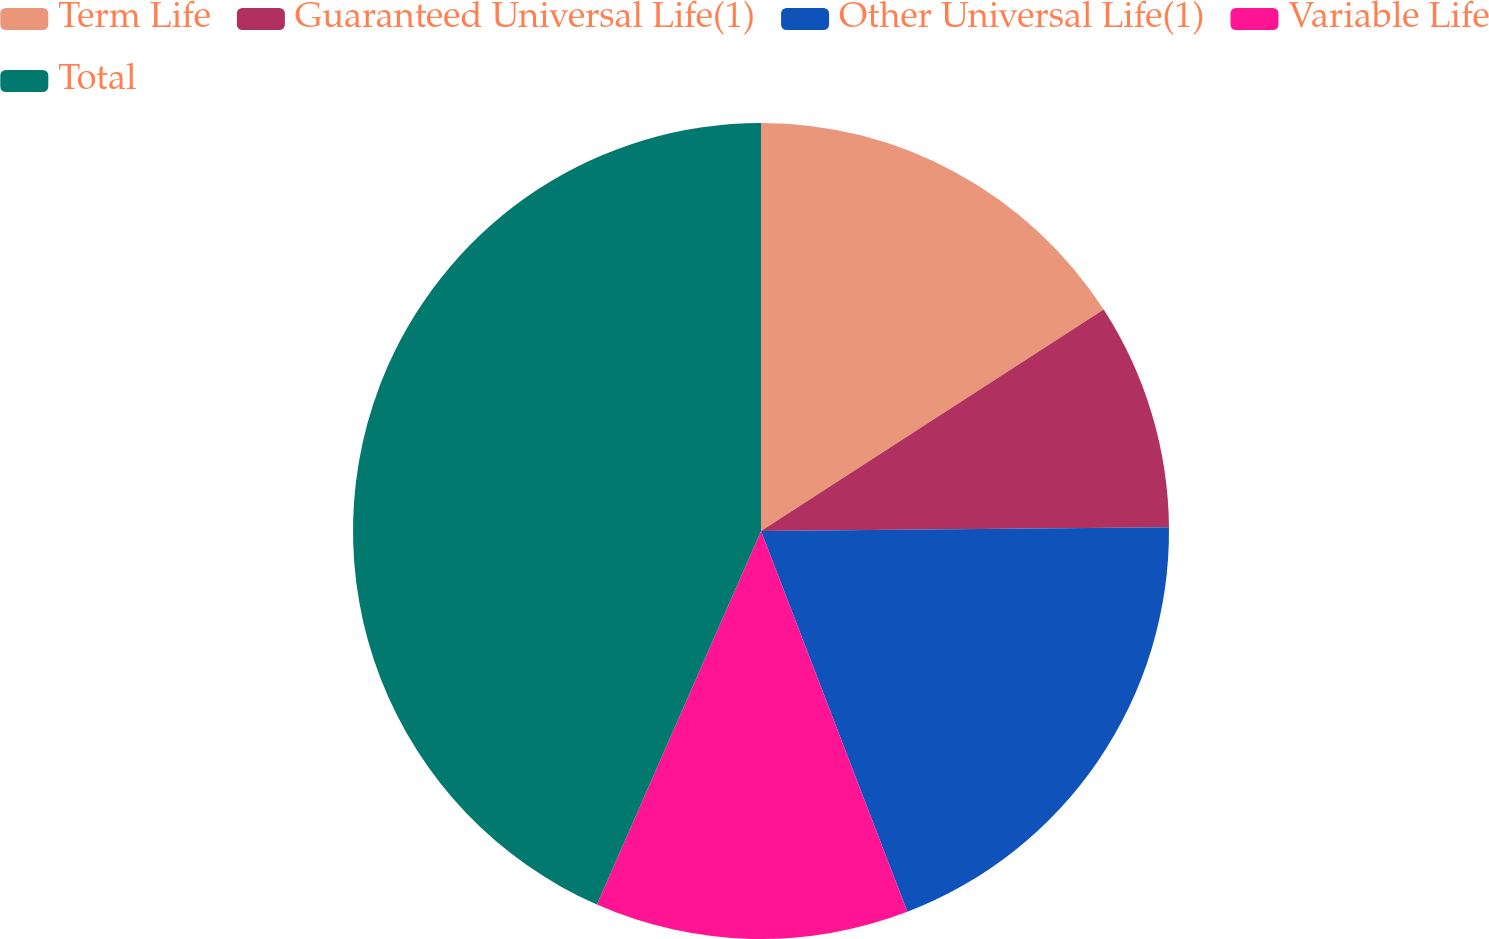Convert chart. <chart><loc_0><loc_0><loc_500><loc_500><pie_chart><fcel>Term Life<fcel>Guaranteed Universal Life(1)<fcel>Other Universal Life(1)<fcel>Variable Life<fcel>Total<nl><fcel>15.87%<fcel>8.98%<fcel>19.31%<fcel>12.43%<fcel>43.41%<nl></chart> 